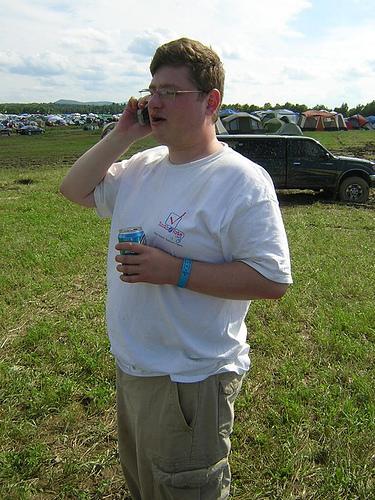What are the children doing?
Be succinct. Talking on phone. What is on his wrist?
Concise answer only. Bracelet. What device is the man holding up to his ear?
Be succinct. Cell phone. Does this look like a tailgating party?
Answer briefly. Yes. What type of beer is he holding?
Be succinct. Miller. 